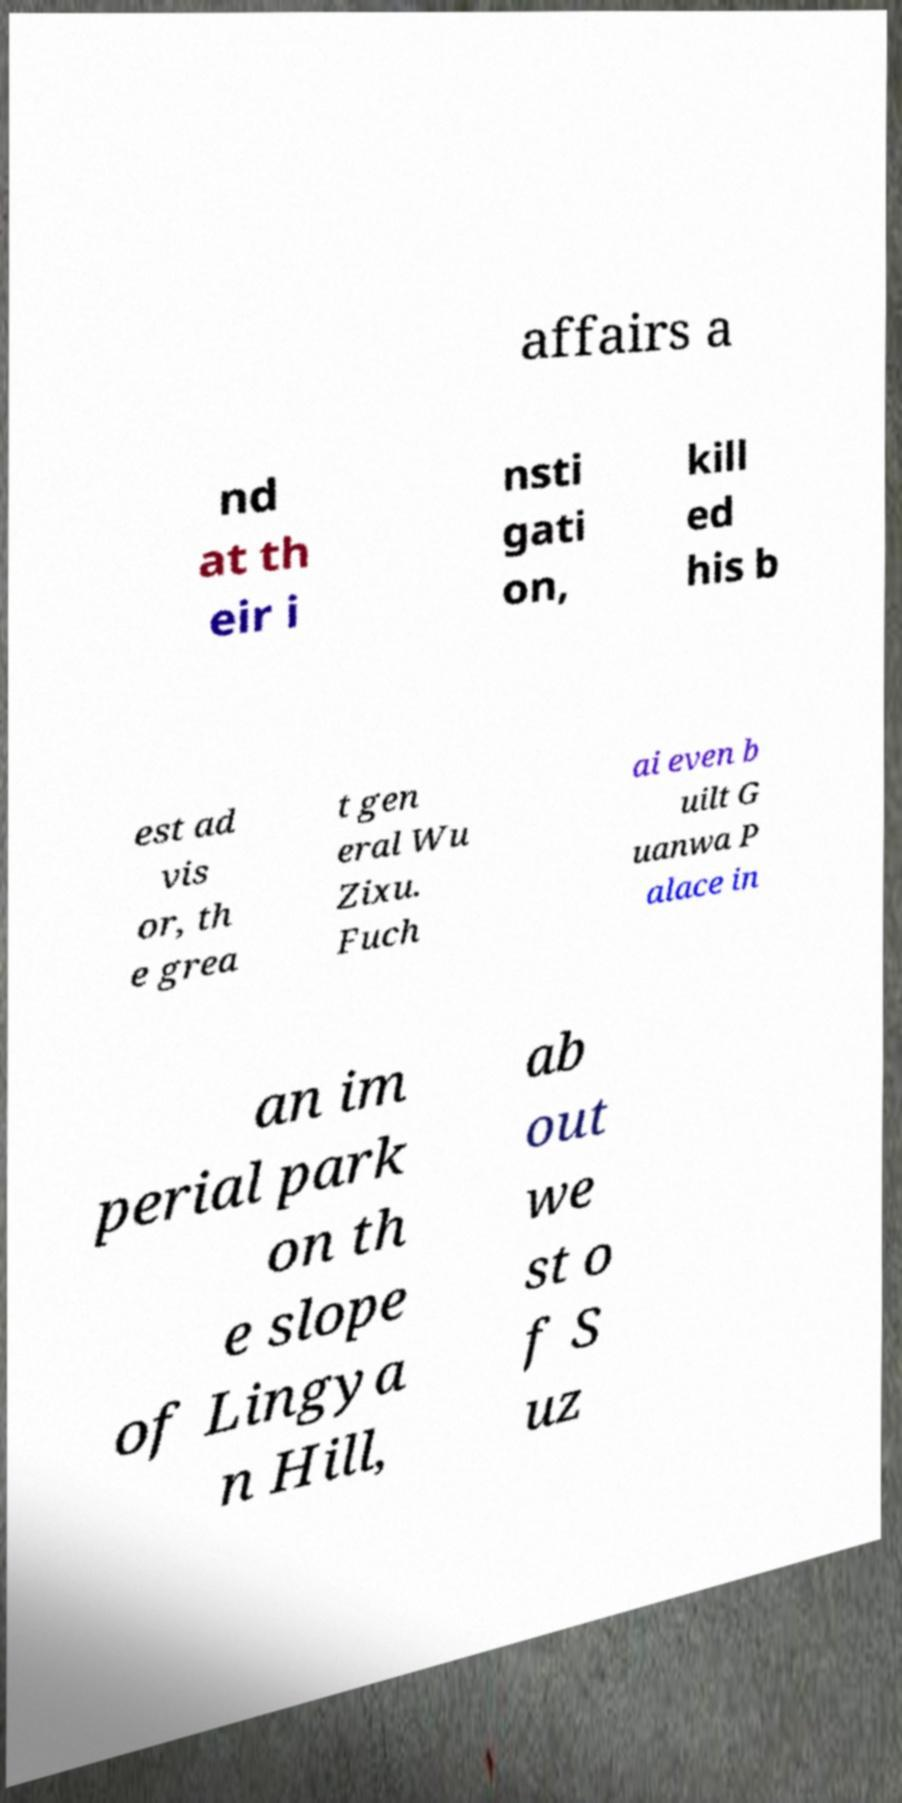Could you extract and type out the text from this image? affairs a nd at th eir i nsti gati on, kill ed his b est ad vis or, th e grea t gen eral Wu Zixu. Fuch ai even b uilt G uanwa P alace in an im perial park on th e slope of Lingya n Hill, ab out we st o f S uz 